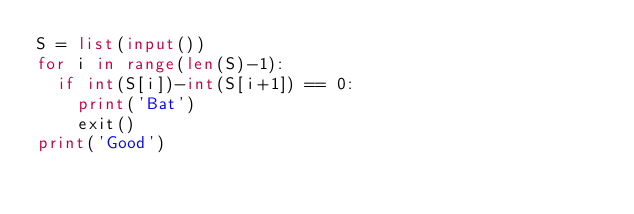Convert code to text. <code><loc_0><loc_0><loc_500><loc_500><_Python_>S = list(input())
for i in range(len(S)-1):
  if int(S[i])-int(S[i+1]) == 0:
    print('Bat')
    exit()
print('Good')</code> 